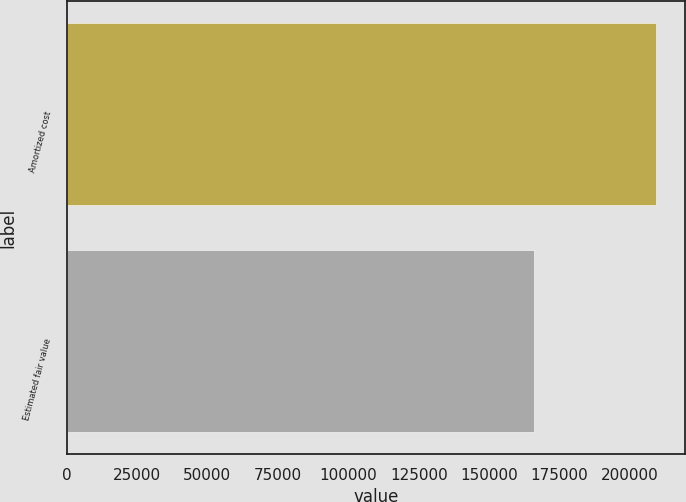Convert chart. <chart><loc_0><loc_0><loc_500><loc_500><bar_chart><fcel>Amortized cost<fcel>Estimated fair value<nl><fcel>209107<fcel>165860<nl></chart> 